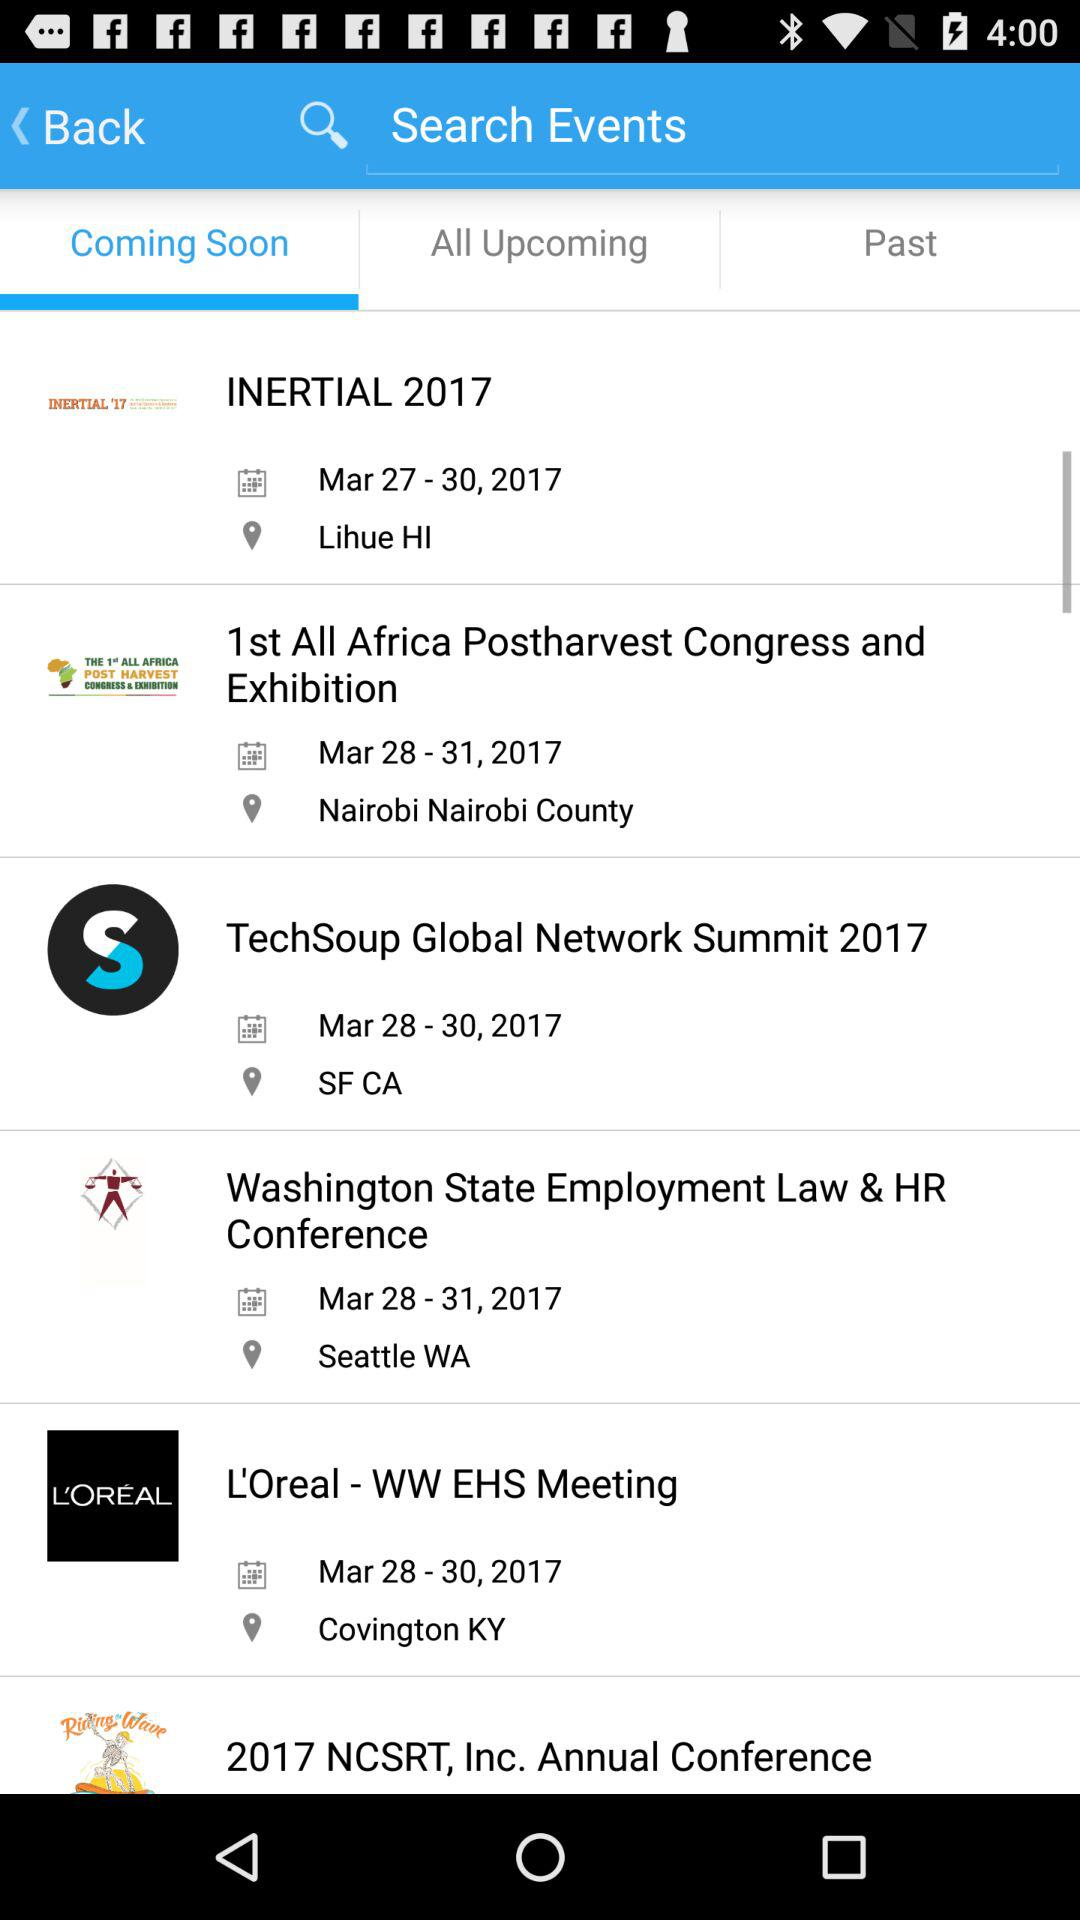What is the location of "INERTIAL 2017" event? The location of "INERTIAL 2017" event is Lihue, HI. 